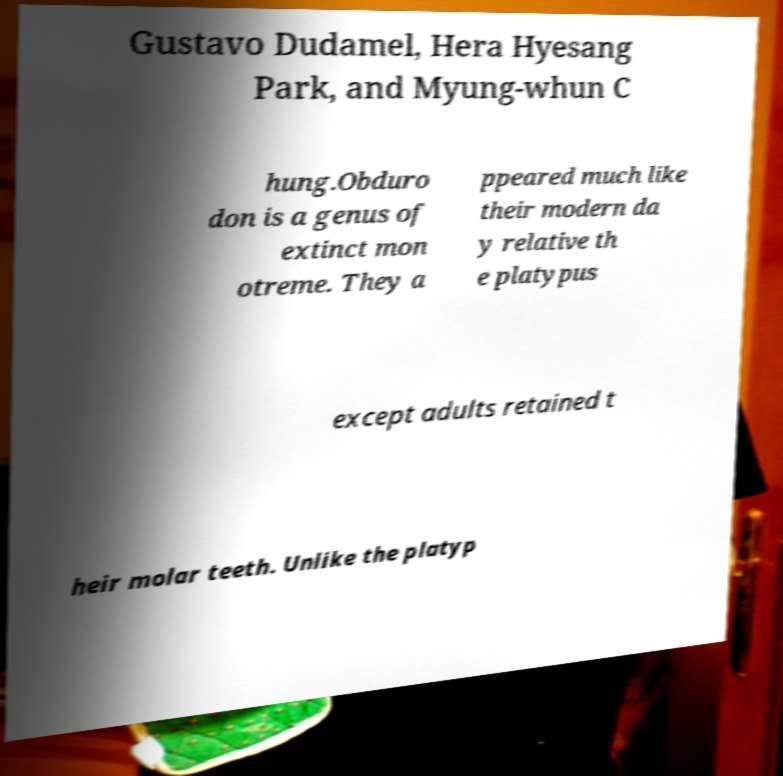Can you accurately transcribe the text from the provided image for me? Gustavo Dudamel, Hera Hyesang Park, and Myung-whun C hung.Obduro don is a genus of extinct mon otreme. They a ppeared much like their modern da y relative th e platypus except adults retained t heir molar teeth. Unlike the platyp 